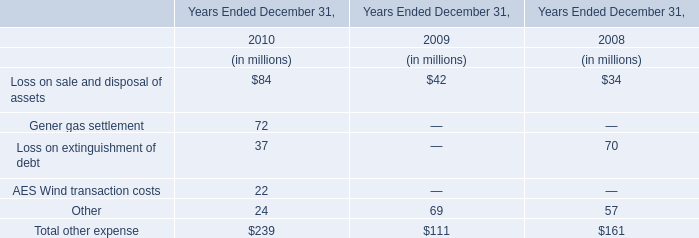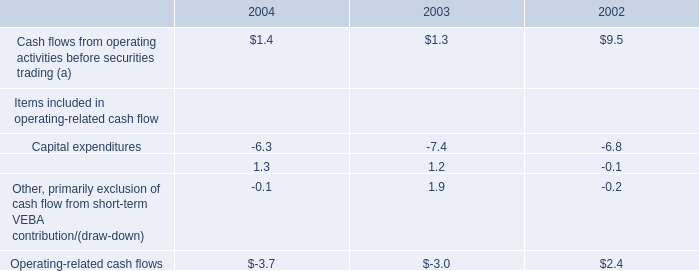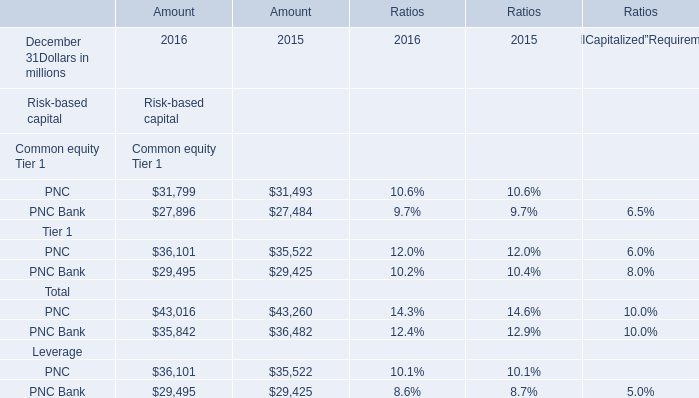What's the growth rate of the Amount for Risk-based capital Tier 1: PNC on December 31 in 2016? 
Computations: ((36101 - 35522) / 35522)
Answer: 0.0163. 